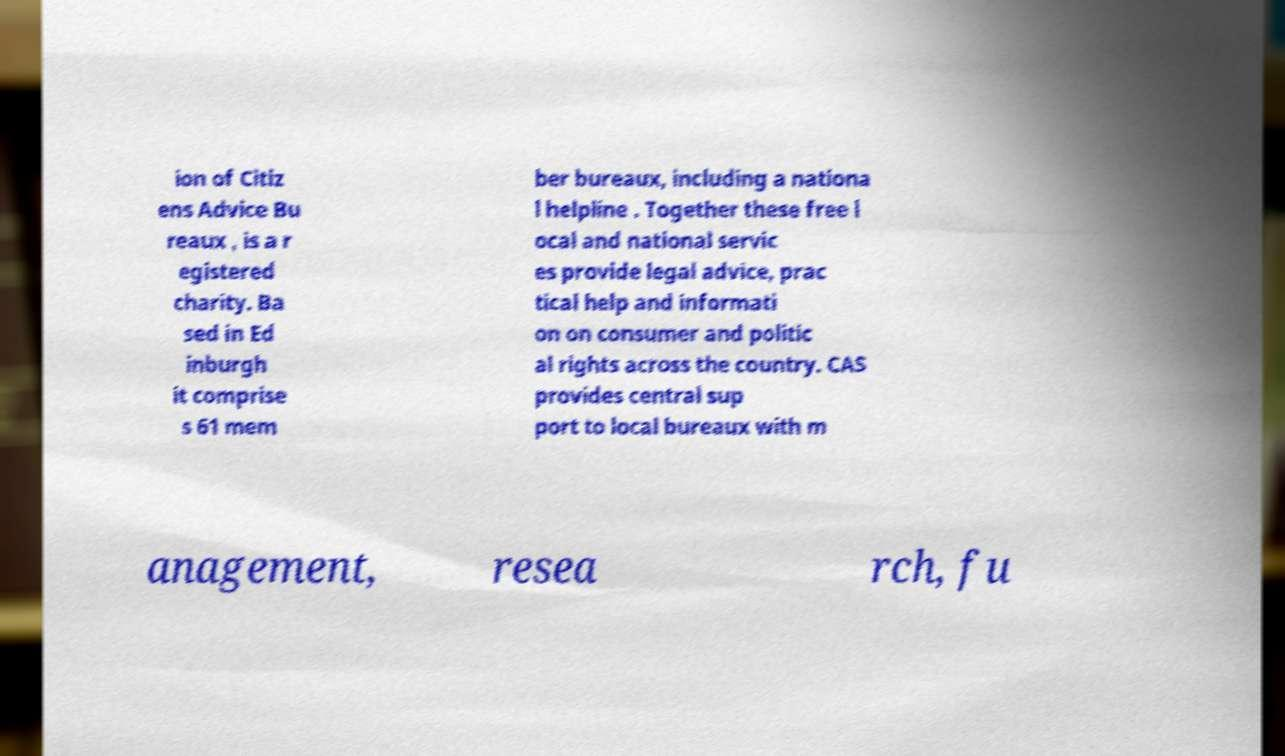Could you assist in decoding the text presented in this image and type it out clearly? ion of Citiz ens Advice Bu reaux , is a r egistered charity. Ba sed in Ed inburgh it comprise s 61 mem ber bureaux, including a nationa l helpline . Together these free l ocal and national servic es provide legal advice, prac tical help and informati on on consumer and politic al rights across the country. CAS provides central sup port to local bureaux with m anagement, resea rch, fu 